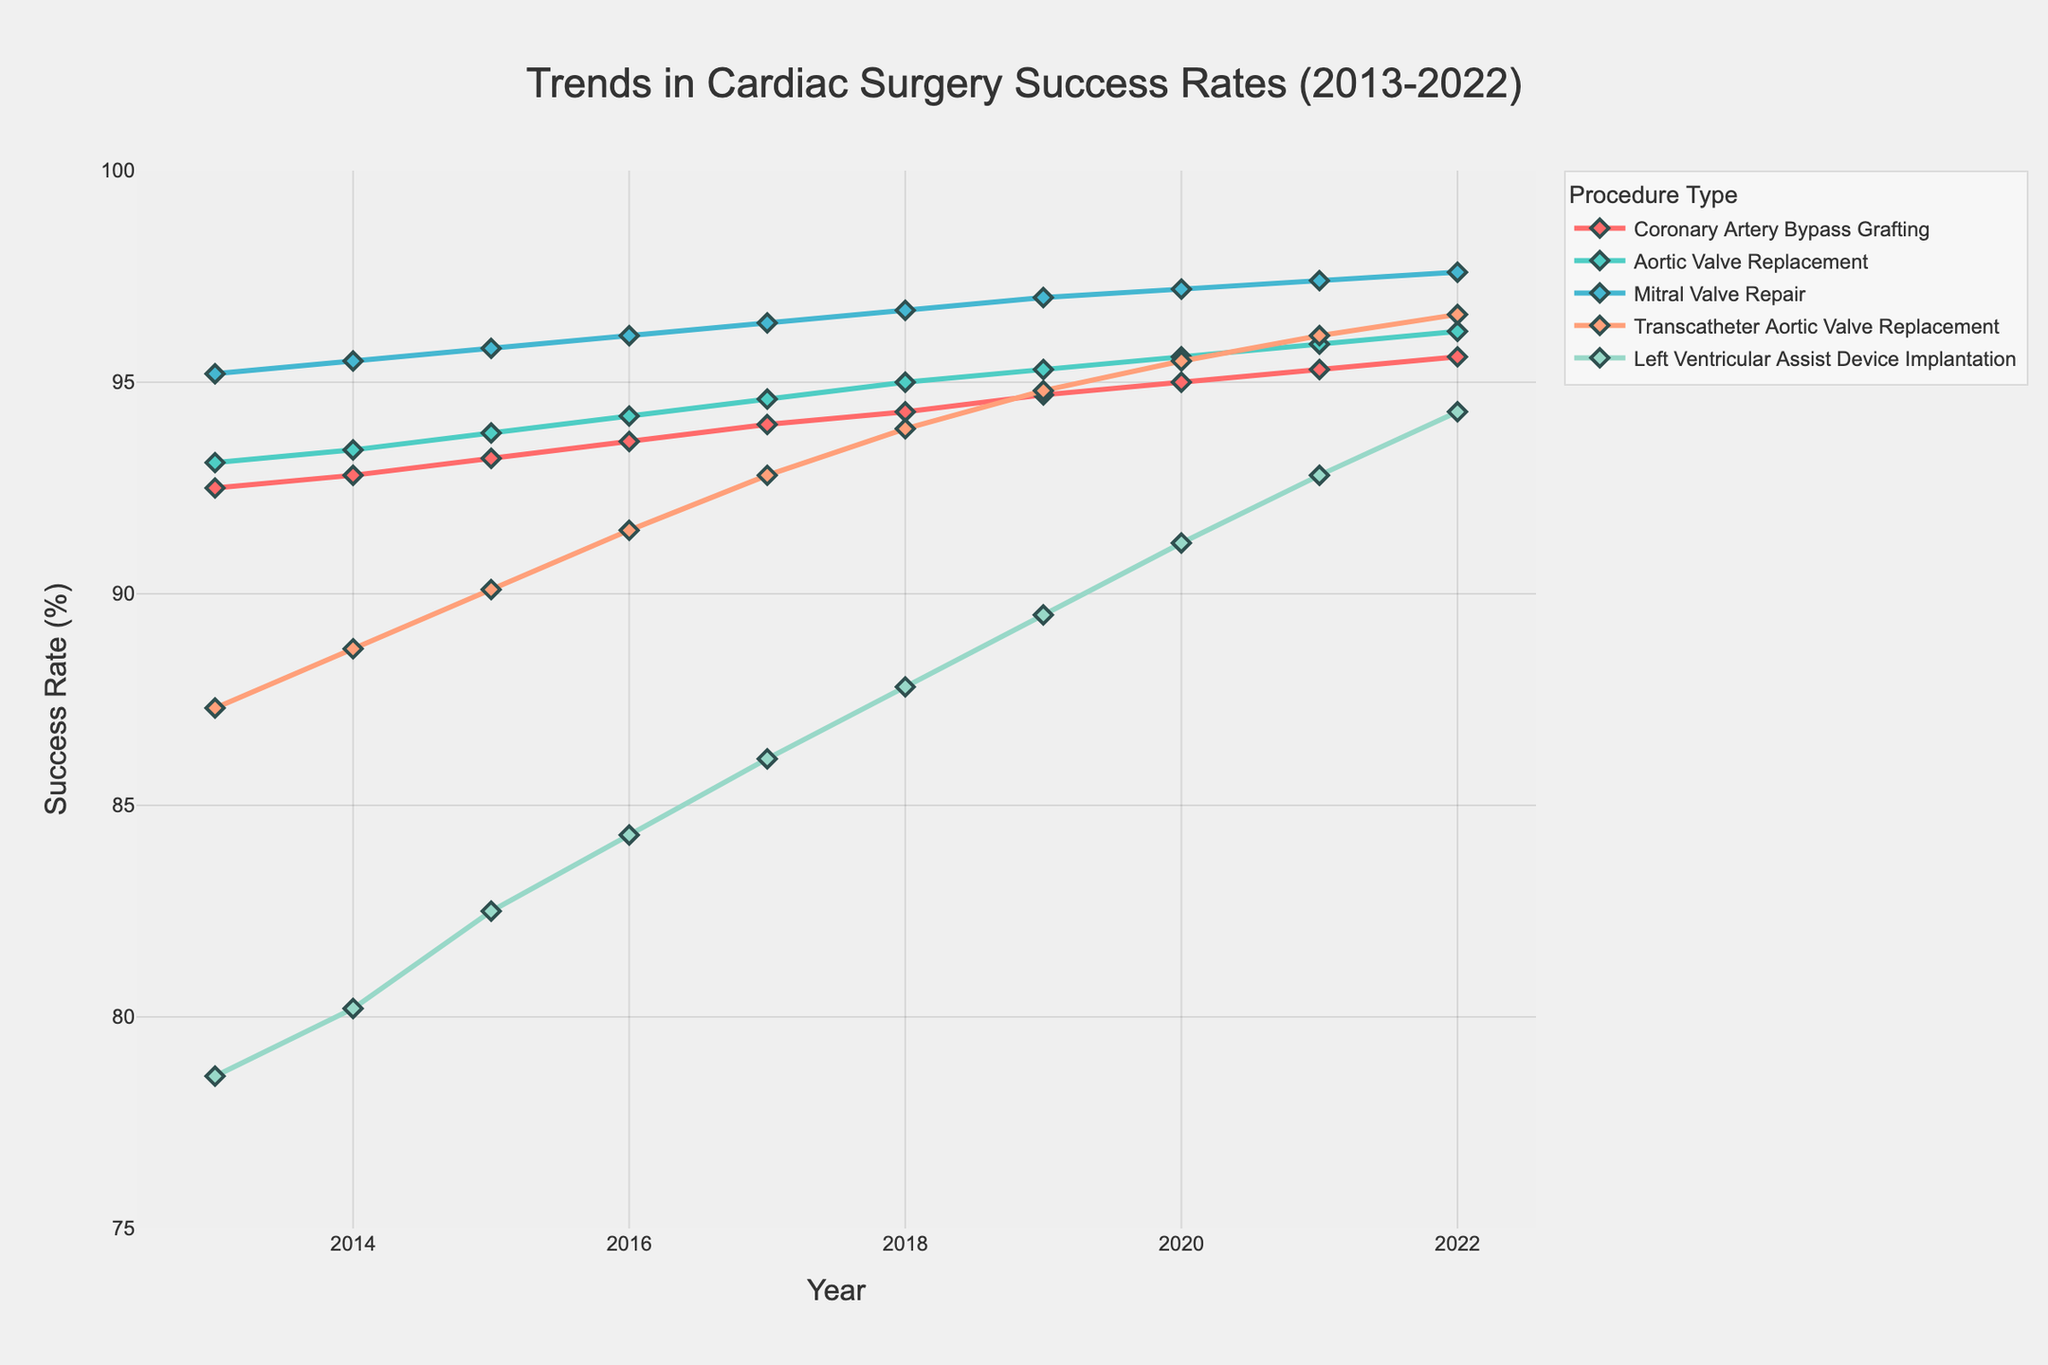What's the overall trend in success rates for Coronary Artery Bypass Grafting from 2013 to 2022? The trend shows a consistent increase in the success rates for Coronary Artery Bypass Grafting from 92.5% in 2013 to 95.6% in 2022.
Answer: Consistent increase Which procedure had the highest success rate in 2022? By examining the success rates for each procedure in 2022, we see that Mitral Valve Repair had the highest success rate at 97.6%.
Answer: Mitral Valve Repair Between 2013 and 2022, which procedure showed the greatest improvement in success rates? By calculating the difference in success rates from 2013 to 2022 for each procedure, we find: 
- Coronary Artery Bypass Grafting: 95.6 - 92.5 = 3.1
- Aortic Valve Replacement: 96.2 - 93.1 = 3.1
- Mitral Valve Repair: 97.6 - 95.2 = 2.4
- Transcatheter Aortic Valve Replacement: 96.6 - 87.3 = 9.3
- Left Ventricular Assist Device Implantation: 94.3 - 78.6 = 15.7
The Left Ventricular Assist Device Implantation showed the greatest improvement.
Answer: Left Ventricular Assist Device Implantation Which year did the success rate for Transcatheter Aortic Valve Replacement first exceed 90%? By examining the success rates for Transcatheter Aortic Valve Replacement, we see that it first exceeded 90% in 2015 with a success rate of 90.1%.
Answer: 2015 How does the success rate of Aortic Valve Replacement in 2016 compare to that in 2020? The success rate of Aortic Valve Replacement in 2016 was 94.2%, and in 2020 it was 95.6%. So, the success rate increased from 2016 to 2020.
Answer: Increased Between Mitral Valve Repair and Left Ventricular Assist Device Implantation, which had a higher success rate in 2019? The success rate in 2019 for Mitral Valve Repair was 97.0%, while for Left Ventricular Assist Device Implantation it was 89.5%. Thus, Mitral Valve Repair had a higher success rate in 2019.
Answer: Mitral Valve Repair Calculate the average success rate of Coronary Artery Bypass Grafting over the decade (2013-2022). To find the average success rate, sum all annual rates from 2013 to 2022 and divide by the number of years: 
(92.5 + 92.8 + 93.2 + 93.6 + 94.0 + 94.3 + 94.7 + 95.0 + 95.3 + 95.6) / 10 = 94.1.
Answer: 94.1% In what year did the success rate for Mitral Valve Repair reach 97%? The success rate for Mitral Valve Repair reached 97% in 2019.
Answer: 2019 Which procedure consistently had the lowest success rate from 2013 to 2022? Left Ventricular Assist Device Implantation had the lowest success rate in each year from 2013 to 2022 when comparing all procedures.
Answer: Left Ventricular Assist Device Implantation What is the difference in success rates between Aortic Valve Replacement and Transcatheter Aortic Valve Replacement in 2022? The success rate of Aortic Valve Replacement in 2022 is 96.2%, and for Transcatheter Aortic Valve Replacement it is 96.6%. The difference is 96.6% - 96.2% = 0.4%.
Answer: 0.4% 